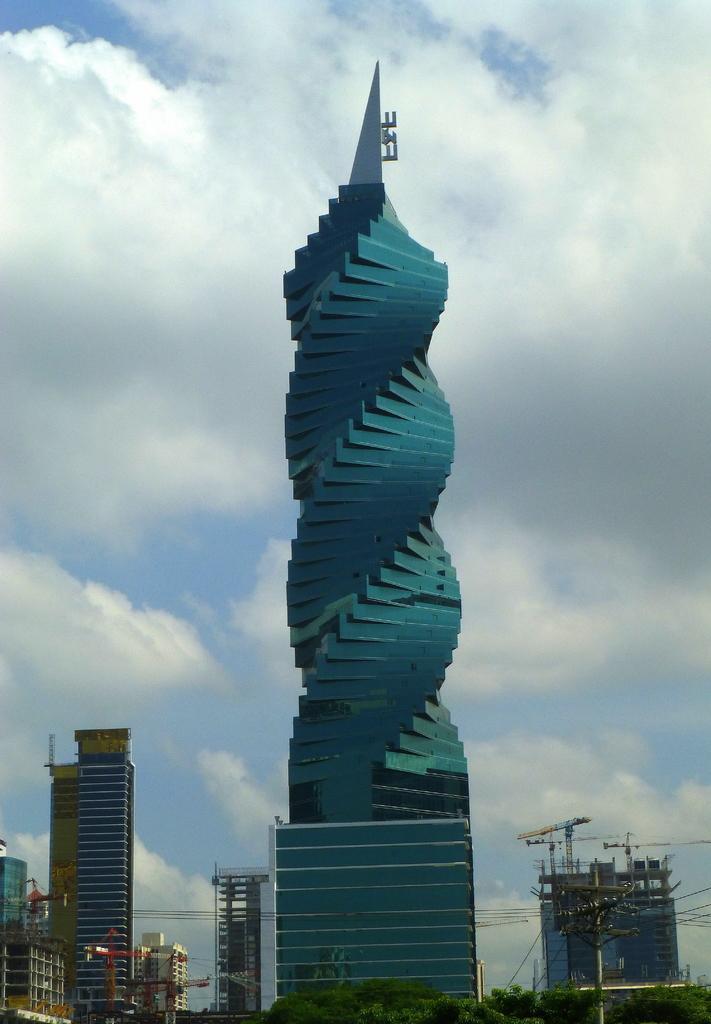Can you describe this image briefly? In this picture I can observe a building which is in blue color. On the left side there are some buildings. I can observe trees on the bottom of the picture. In the background there are some clouds in the sky. 